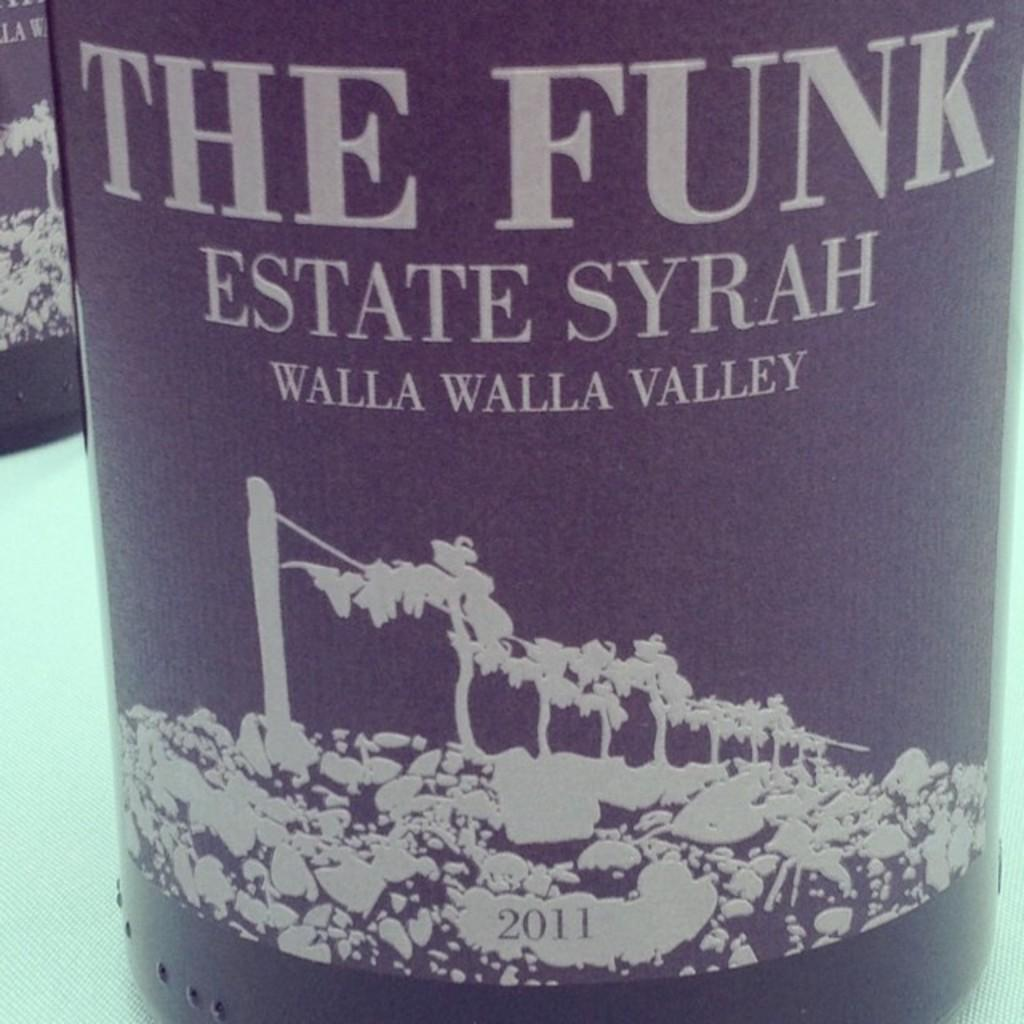<image>
Create a compact narrative representing the image presented. an estate syrah bottle that has the funk on it 